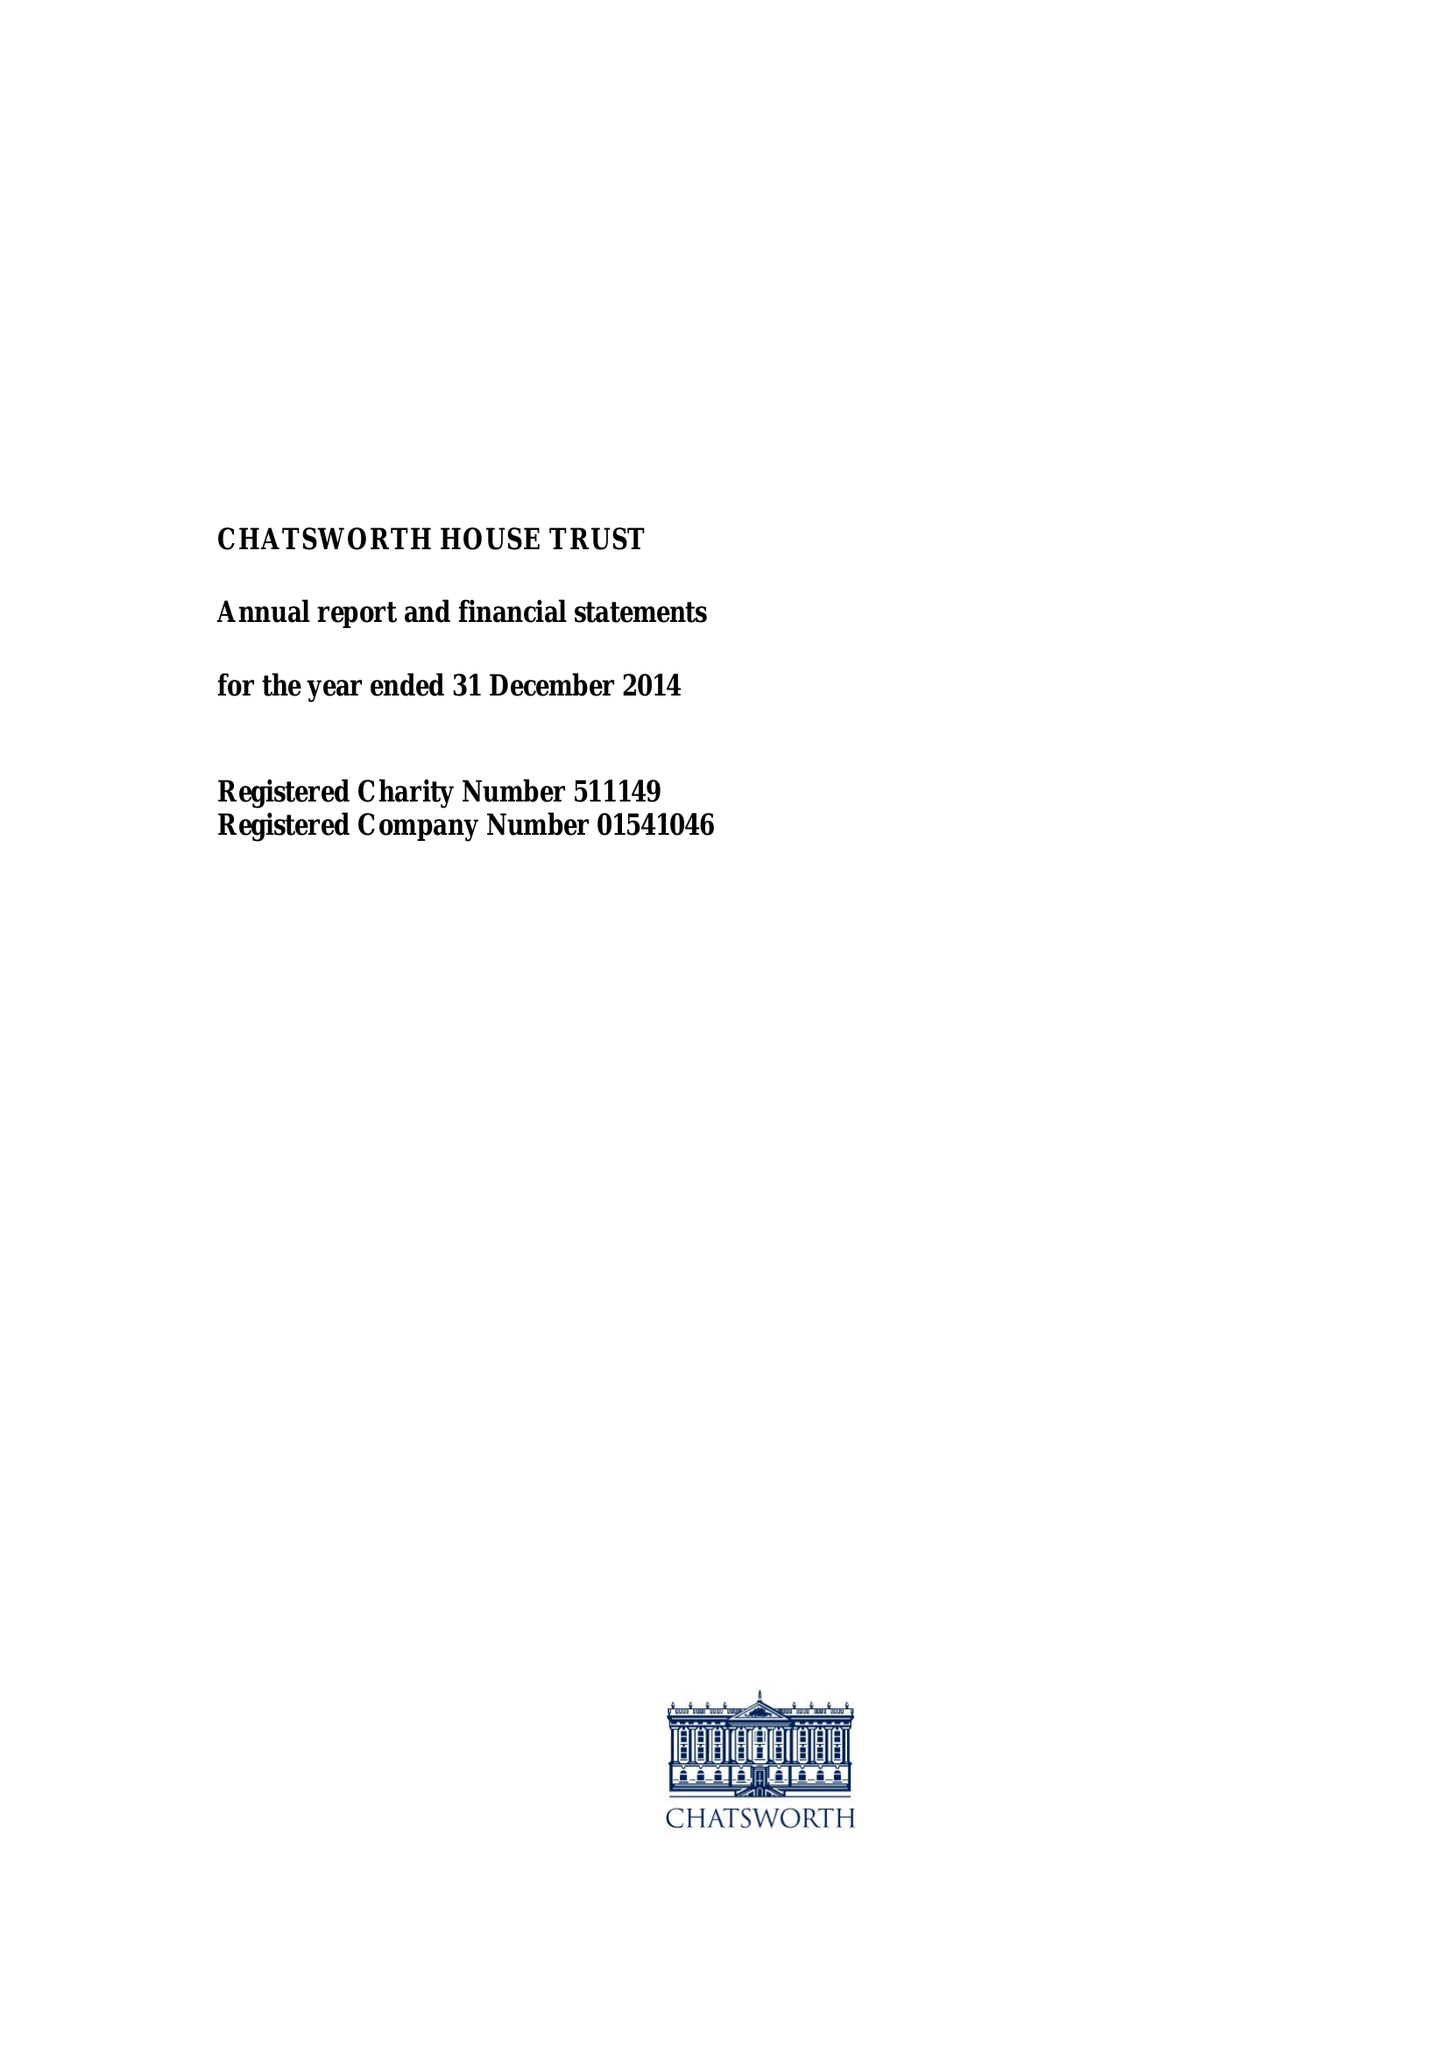What is the value for the address__postcode?
Answer the question using a single word or phrase. DE45 1PJ 